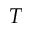<formula> <loc_0><loc_0><loc_500><loc_500>T</formula> 